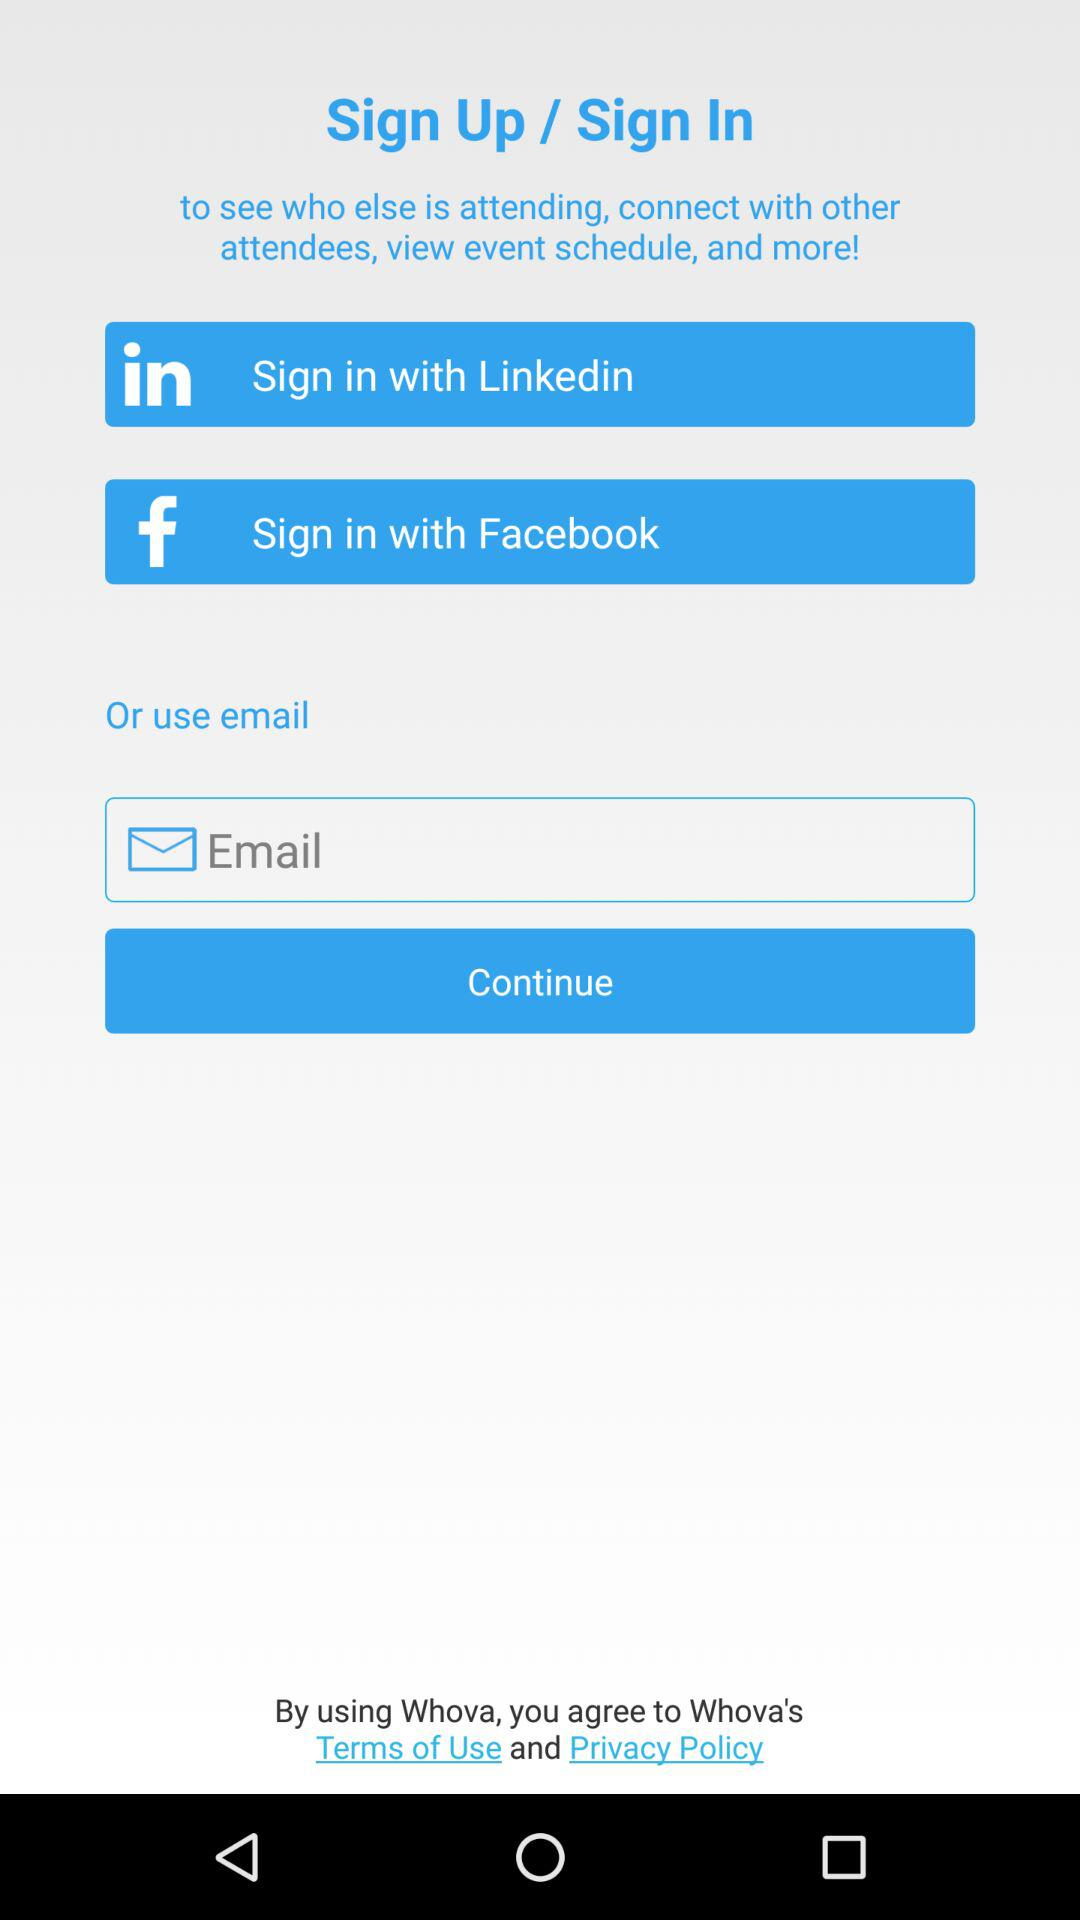How many sign in options are there?
Answer the question using a single word or phrase. 3 